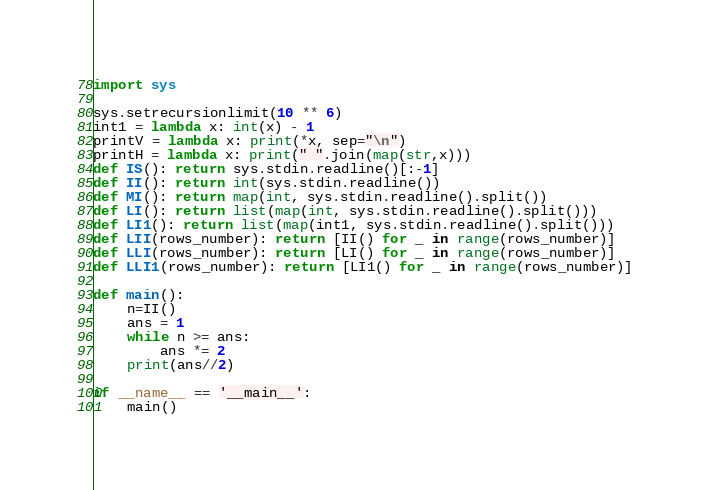Convert code to text. <code><loc_0><loc_0><loc_500><loc_500><_Python_>import sys

sys.setrecursionlimit(10 ** 6)
int1 = lambda x: int(x) - 1
printV = lambda x: print(*x, sep="\n")
printH = lambda x: print(" ".join(map(str,x)))
def IS(): return sys.stdin.readline()[:-1]
def II(): return int(sys.stdin.readline())
def MI(): return map(int, sys.stdin.readline().split())
def LI(): return list(map(int, sys.stdin.readline().split()))
def LI1(): return list(map(int1, sys.stdin.readline().split()))
def LII(rows_number): return [II() for _ in range(rows_number)]
def LLI(rows_number): return [LI() for _ in range(rows_number)]
def LLI1(rows_number): return [LI1() for _ in range(rows_number)]

def main():
	n=II()
	ans = 1
	while n >= ans:
		ans *= 2
	print(ans//2)

if __name__ == '__main__':
	main()</code> 